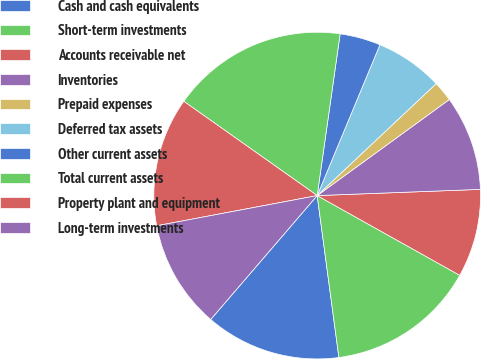Convert chart. <chart><loc_0><loc_0><loc_500><loc_500><pie_chart><fcel>Cash and cash equivalents<fcel>Short-term investments<fcel>Accounts receivable net<fcel>Inventories<fcel>Prepaid expenses<fcel>Deferred tax assets<fcel>Other current assets<fcel>Total current assets<fcel>Property plant and equipment<fcel>Long-term investments<nl><fcel>13.42%<fcel>14.76%<fcel>8.72%<fcel>9.4%<fcel>2.01%<fcel>6.71%<fcel>4.03%<fcel>17.45%<fcel>12.75%<fcel>10.74%<nl></chart> 